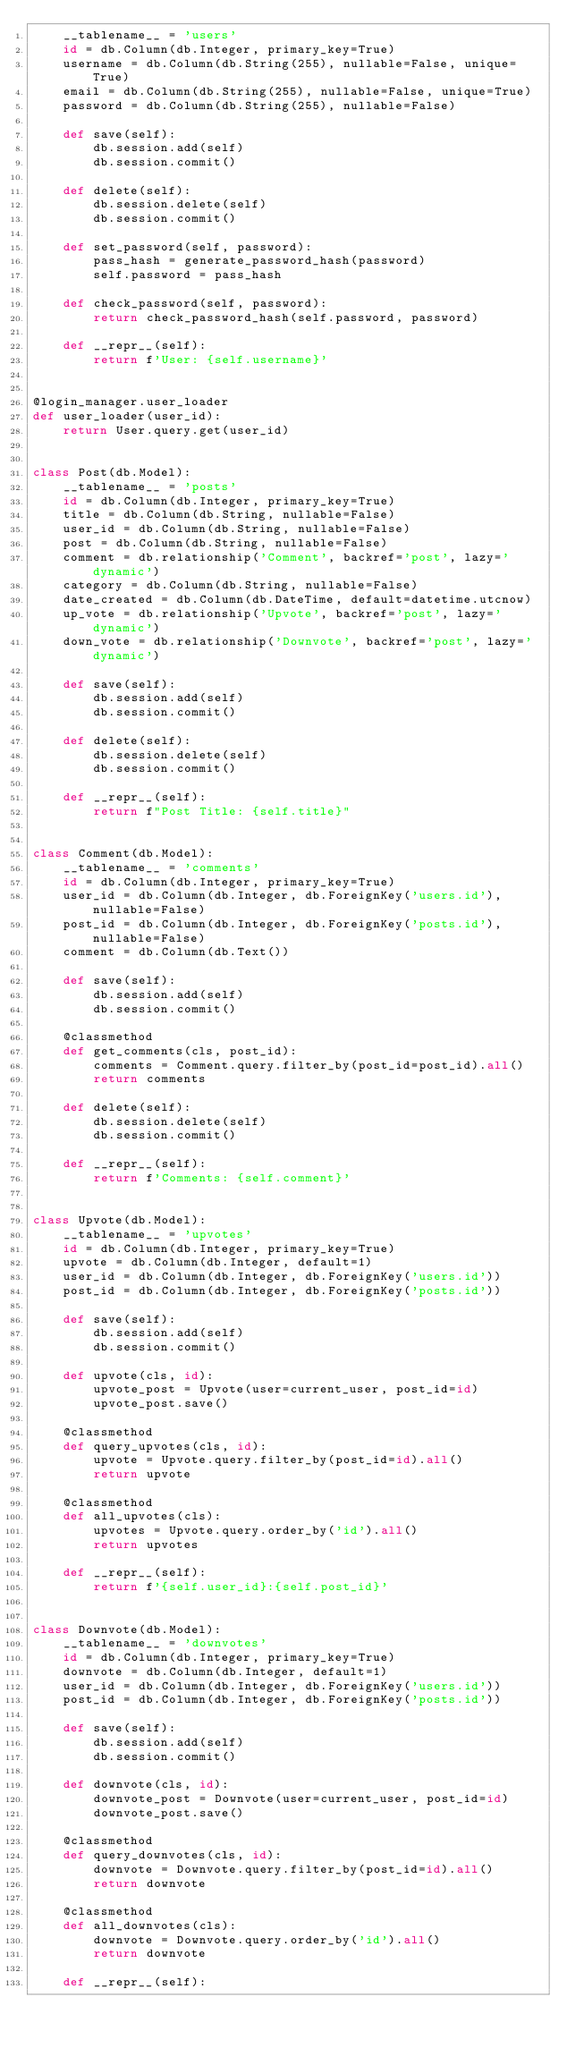Convert code to text. <code><loc_0><loc_0><loc_500><loc_500><_Python_>    __tablename__ = 'users'
    id = db.Column(db.Integer, primary_key=True)
    username = db.Column(db.String(255), nullable=False, unique=True)
    email = db.Column(db.String(255), nullable=False, unique=True)
    password = db.Column(db.String(255), nullable=False)

    def save(self):
        db.session.add(self)
        db.session.commit()

    def delete(self):
        db.session.delete(self)
        db.session.commit()

    def set_password(self, password):
        pass_hash = generate_password_hash(password)
        self.password = pass_hash

    def check_password(self, password):
        return check_password_hash(self.password, password)

    def __repr__(self):
        return f'User: {self.username}'


@login_manager.user_loader
def user_loader(user_id):
    return User.query.get(user_id)


class Post(db.Model):
    __tablename__ = 'posts'
    id = db.Column(db.Integer, primary_key=True)
    title = db.Column(db.String, nullable=False)
    user_id = db.Column(db.String, nullable=False)
    post = db.Column(db.String, nullable=False)
    comment = db.relationship('Comment', backref='post', lazy='dynamic')
    category = db.Column(db.String, nullable=False)
    date_created = db.Column(db.DateTime, default=datetime.utcnow)
    up_vote = db.relationship('Upvote', backref='post', lazy='dynamic')
    down_vote = db.relationship('Downvote', backref='post', lazy='dynamic')

    def save(self):
        db.session.add(self)
        db.session.commit()

    def delete(self):
        db.session.delete(self)
        db.session.commit()

    def __repr__(self):
        return f"Post Title: {self.title}"


class Comment(db.Model):
    __tablename__ = 'comments'
    id = db.Column(db.Integer, primary_key=True)
    user_id = db.Column(db.Integer, db.ForeignKey('users.id'), nullable=False)
    post_id = db.Column(db.Integer, db.ForeignKey('posts.id'), nullable=False)
    comment = db.Column(db.Text())

    def save(self):
        db.session.add(self)
        db.session.commit()

    @classmethod
    def get_comments(cls, post_id):
        comments = Comment.query.filter_by(post_id=post_id).all()
        return comments

    def delete(self):
        db.session.delete(self)
        db.session.commit()

    def __repr__(self):
        return f'Comments: {self.comment}'


class Upvote(db.Model):
    __tablename__ = 'upvotes'
    id = db.Column(db.Integer, primary_key=True)
    upvote = db.Column(db.Integer, default=1)
    user_id = db.Column(db.Integer, db.ForeignKey('users.id'))
    post_id = db.Column(db.Integer, db.ForeignKey('posts.id'))

    def save(self):
        db.session.add(self)
        db.session.commit()

    def upvote(cls, id):
        upvote_post = Upvote(user=current_user, post_id=id)
        upvote_post.save()

    @classmethod
    def query_upvotes(cls, id):
        upvote = Upvote.query.filter_by(post_id=id).all()
        return upvote

    @classmethod
    def all_upvotes(cls):
        upvotes = Upvote.query.order_by('id').all()
        return upvotes

    def __repr__(self):
        return f'{self.user_id}:{self.post_id}'


class Downvote(db.Model):
    __tablename__ = 'downvotes'
    id = db.Column(db.Integer, primary_key=True)
    downvote = db.Column(db.Integer, default=1)
    user_id = db.Column(db.Integer, db.ForeignKey('users.id'))
    post_id = db.Column(db.Integer, db.ForeignKey('posts.id'))

    def save(self):
        db.session.add(self)
        db.session.commit()

    def downvote(cls, id):
        downvote_post = Downvote(user=current_user, post_id=id)
        downvote_post.save()

    @classmethod
    def query_downvotes(cls, id):
        downvote = Downvote.query.filter_by(post_id=id).all()
        return downvote

    @classmethod
    def all_downvotes(cls):
        downvote = Downvote.query.order_by('id').all()
        return downvote

    def __repr__(self):</code> 